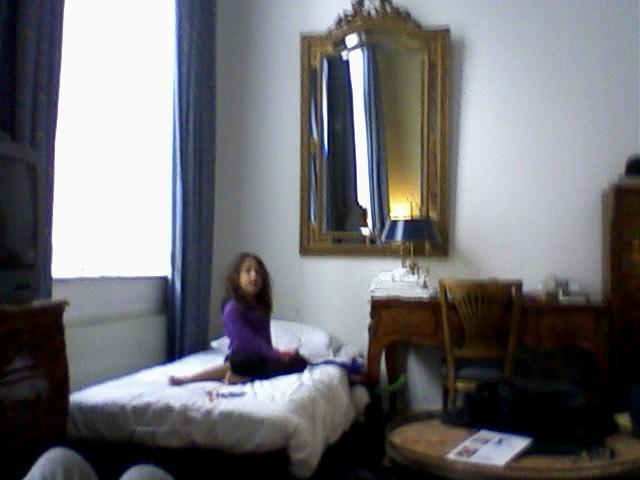Why is the image blurred? unfocused 